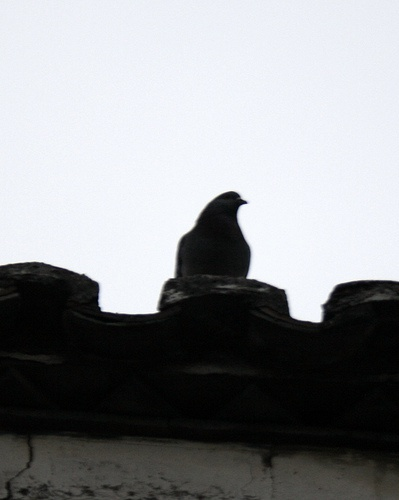Describe the objects in this image and their specific colors. I can see a bird in lavender, black, gray, lightgray, and darkgray tones in this image. 